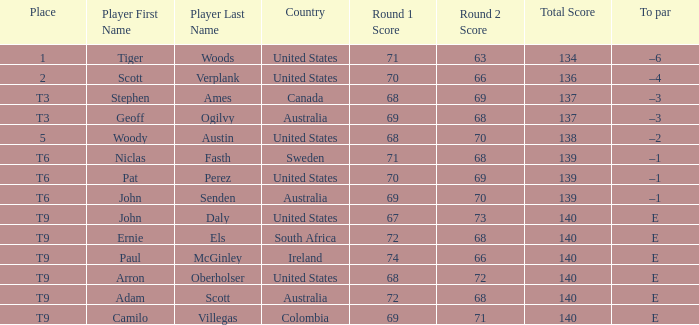Which country has a score of 70-66=136? United States. 